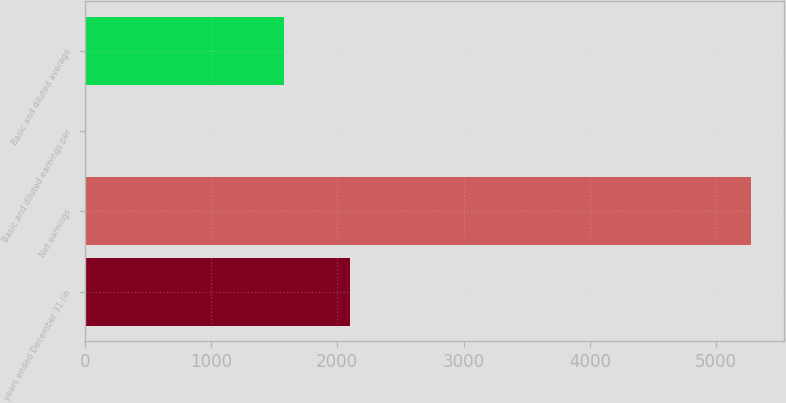<chart> <loc_0><loc_0><loc_500><loc_500><bar_chart><fcel>years ended December 31 (in<fcel>Net earnings<fcel>Basic and diluted earnings per<fcel>Basic and diluted average<nl><fcel>2104.16<fcel>5275<fcel>3.35<fcel>1577<nl></chart> 